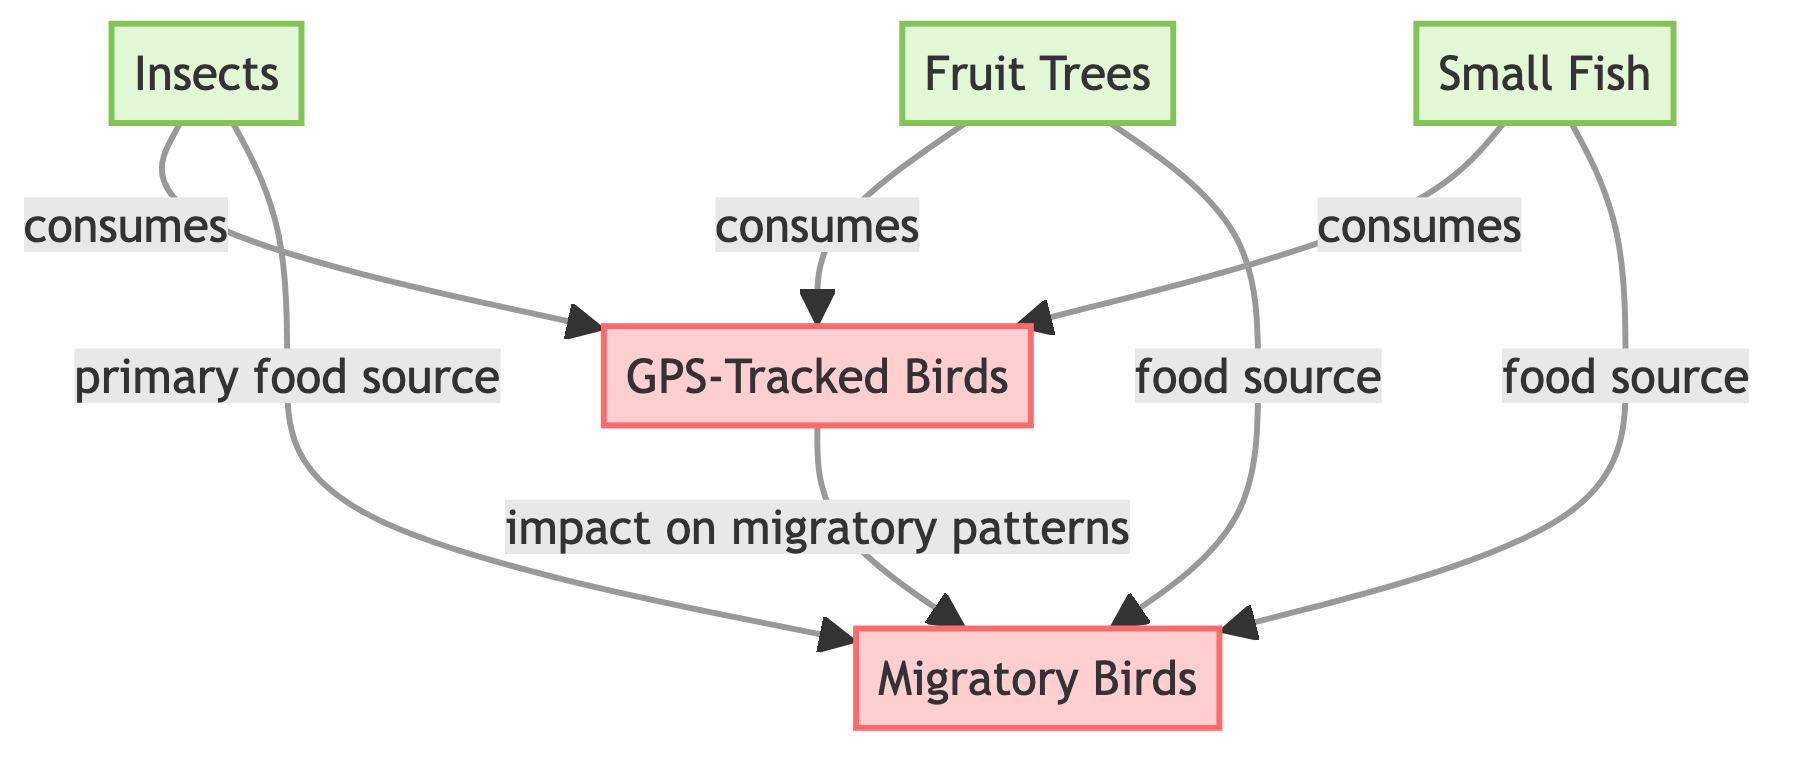What are the three food sources for GPS-tracked birds? The diagram shows three food sources connected to the node representing GPS-tracked birds: insects, fruit trees, and small fish. Each of these food sources is directly linked to the GPS-tracked birds indicating that they consume them.
Answer: insects, fruit trees, small fish How many nodes are represented in the diagram? The diagram contains a total of five nodes: three food sources (insects, fruit trees, small fish), one node for GPS-tracked birds, and one for migratory birds. This can be counted by looking at each distinct element visually represented in the diagram.
Answer: 5 What effect do GPS-tracked birds have on migratory birds? The arrow from GPS-tracked birds to migratory birds labeled "impact on migratory patterns" indicates a direct effect. This shows that the behavior of the GPS-tracked birds influences how migratory birds move and migrate.
Answer: impact on migratory patterns Which food source is a primary source for migratory birds? The diagram specifically labels the connection from insects to migratory birds as "primary food source," which indicates that insects are the main food source for migratory birds.
Answer: insects How many food sources are connected to the GPS-tracked birds? The diagram shows that there are three different food sources— insects, fruit trees, and small fish—connected to the node for GPS-tracked birds. This is evident from the three outgoing arrows from the GPS-tracked birds towards these food sources.
Answer: 3 What types of birds are indicated in the diagram? The diagram identifies two types of birds: GPS-tracked birds and migratory birds. These are specifically labeled with the bird category colors, allowing for clear identification of each type in the diagram flow.
Answer: GPS-tracked birds, migratory birds What relationship does fruit trees have with migratory birds? The connection from fruit trees to migratory birds is labeled as "food source," indicating that fruit trees provide sustenance for migratory birds. The diagram clarifies this relationship visually through the directional arrow.
Answer: food source Which food source is not linked to migratory birds? Looking at the connections in the diagram, all food sources (insects, fruit trees, small fish) have links to migratory birds. However, the question can also explore that the impact of GPS-tracked birds affects migratory birds but does not specify a single food source that lacks a connection. Hence, all food sources have some link.
Answer: none 